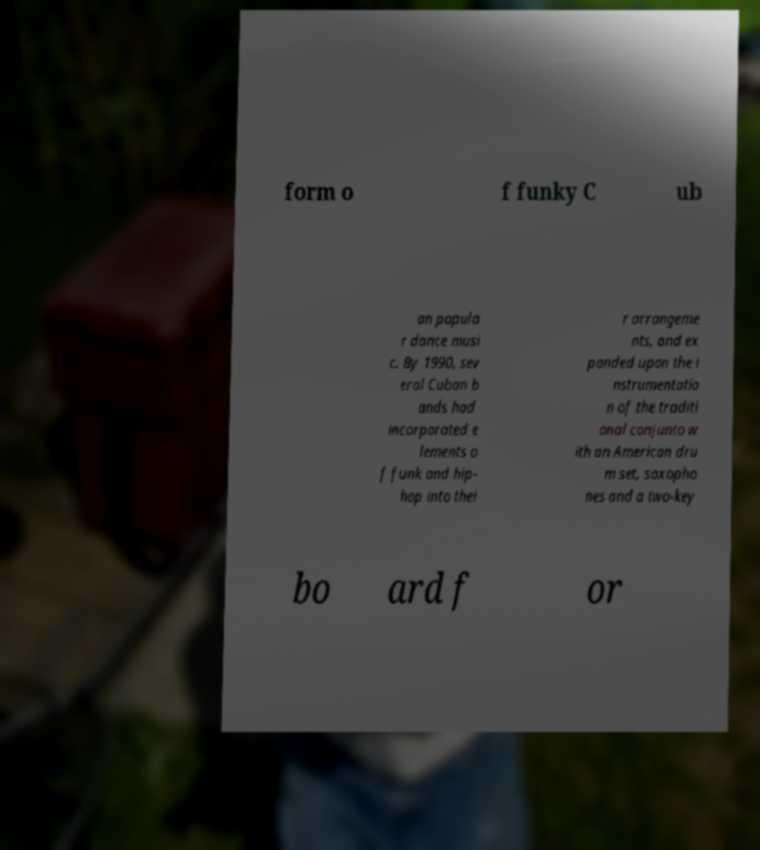Please read and relay the text visible in this image. What does it say? form o f funky C ub an popula r dance musi c. By 1990, sev eral Cuban b ands had incorporated e lements o f funk and hip- hop into thei r arrangeme nts, and ex panded upon the i nstrumentatio n of the traditi onal conjunto w ith an American dru m set, saxopho nes and a two-key bo ard f or 